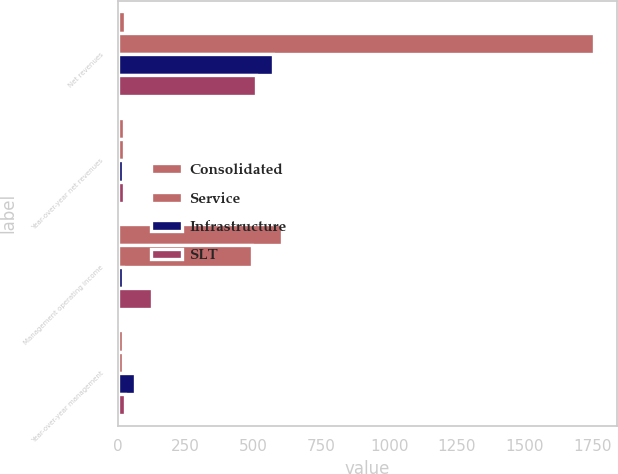Convert chart to OTSL. <chart><loc_0><loc_0><loc_500><loc_500><stacked_bar_chart><ecel><fcel>Net revenues<fcel>Year-over-year net revenues<fcel>Management operating income<fcel>Year-over-year management<nl><fcel>Consolidated<fcel>25<fcel>23<fcel>603.6<fcel>18<nl><fcel>Service<fcel>1753.2<fcel>24<fcel>495.5<fcel>18<nl><fcel>Infrastructure<fcel>573.8<fcel>20<fcel>18.3<fcel>62<nl><fcel>SLT<fcel>509.1<fcel>24<fcel>126.4<fcel>25<nl></chart> 